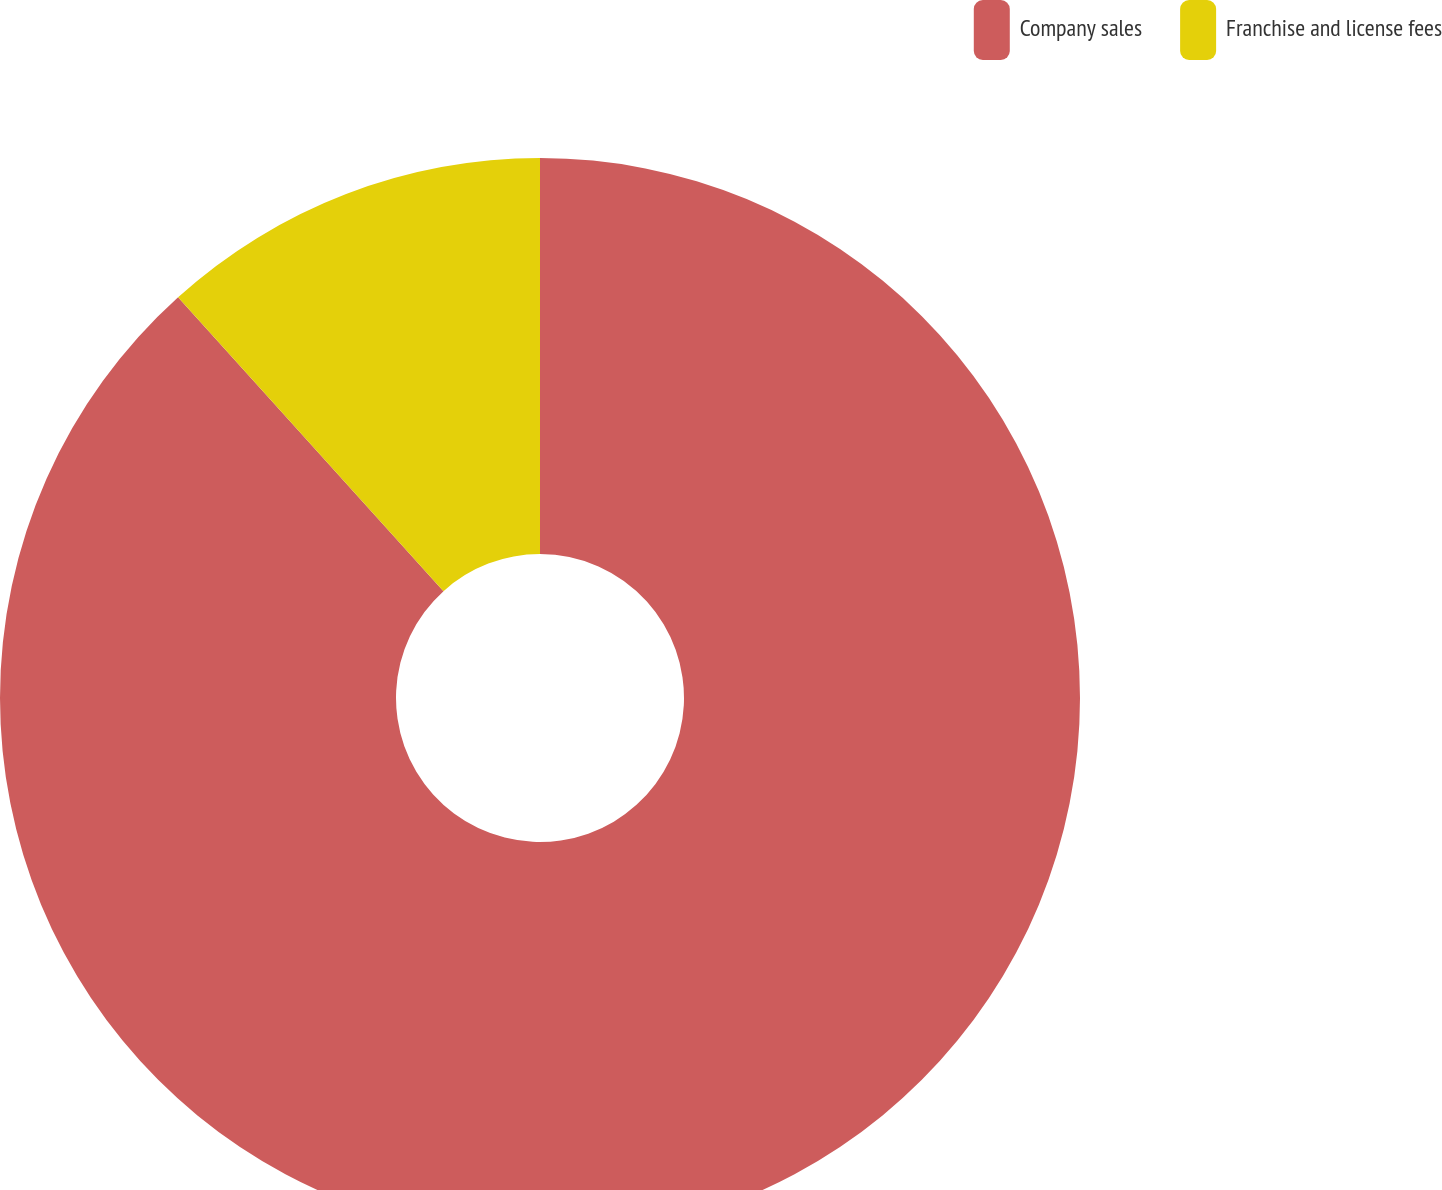<chart> <loc_0><loc_0><loc_500><loc_500><pie_chart><fcel>Company sales<fcel>Franchise and license fees<nl><fcel>88.31%<fcel>11.69%<nl></chart> 